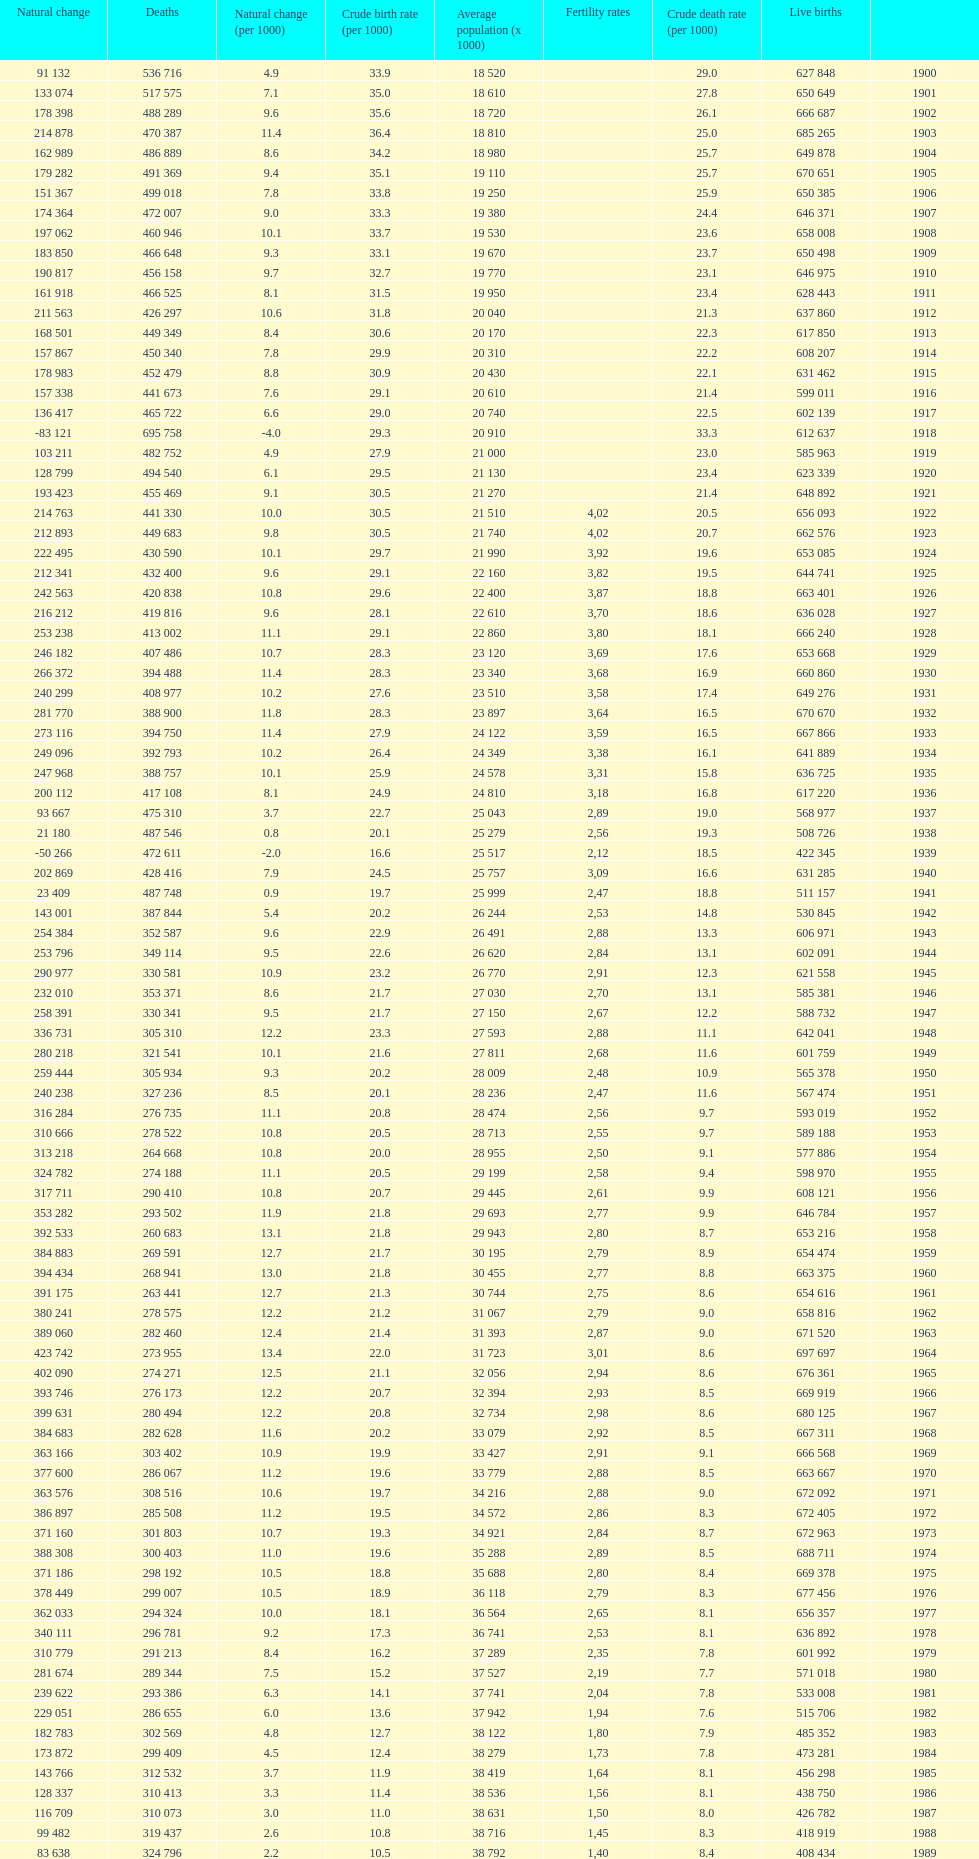Which year has a crude birth rate of 29.1 with a population of 22,860? 1928. 